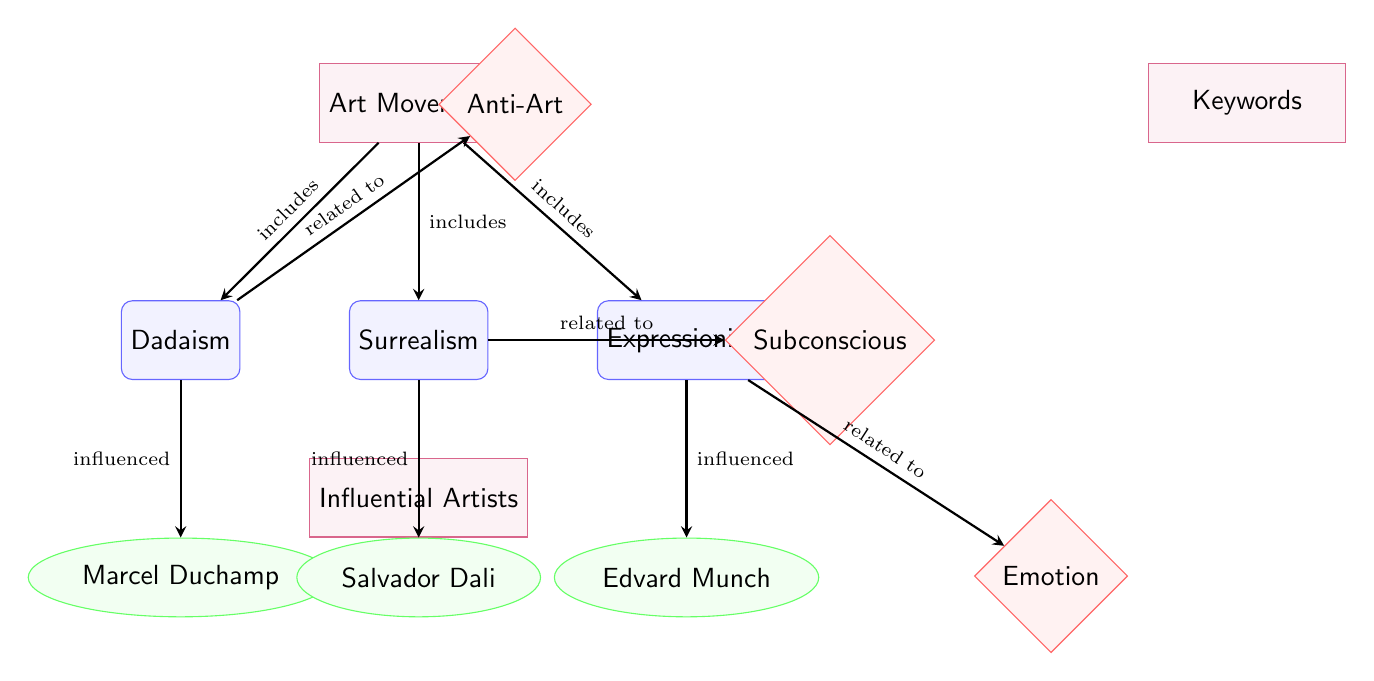What are the three art movements represented in the diagram? The nodes labeled as Dadaism, Surrealism, and Expressionism represent the three art movements illustrated in the diagram.
Answer: Dadaism, Surrealism, Expressionism Who is the influential artist associated with Dadaism? The diagram connects the Dadaism movement to the influential artist Marcel Duchamp, making him the associated artist.
Answer: Marcel Duchamp Which keyword is related to Surrealism? The arrow connecting Surrealism to the keyword 'Subconscious' indicates that it is the keyword related to this art movement.
Answer: Subconscious How many influential artists are represented in the diagram? The diagram lists three influential artists: Marcel Duchamp, Salvador Dali, and Edvard Munch, totaling three artists.
Answer: 3 Which art movement is associated with the keyword 'Emotion'? The diagram shows an arrow from Expressionism to the keyword 'Emotion', indicating this relationship.
Answer: Expressionism What type of relationship is indicated between Dadaism and Marcel Duchamp? The arrow from Dadaism to Marcel Duchamp is labeled 'influenced', which signifies the type of relationship.
Answer: Influenced Which art movement is associated with the keyword 'Anti-Art'? The diagram shows that the keyword 'Anti-Art' is directly connected to the Dadaism movement, establishing this association.
Answer: Dadaism Identify the outlier artist connected to Surrealism. Among the artists, only Salvador Dali is connected to Surrealism, making him the outlier associated with this movement.
Answer: Salvador Dali What is the visual representation type used in the diagram? The diagram employs a flowchart format, using various shapes to represent categories, movements, artists, and keywords.
Answer: Flowchart 